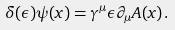<formula> <loc_0><loc_0><loc_500><loc_500>\delta ( \epsilon ) \psi ( x ) = \gamma ^ { \mu } \epsilon \partial _ { \mu } A ( x ) \, .</formula> 